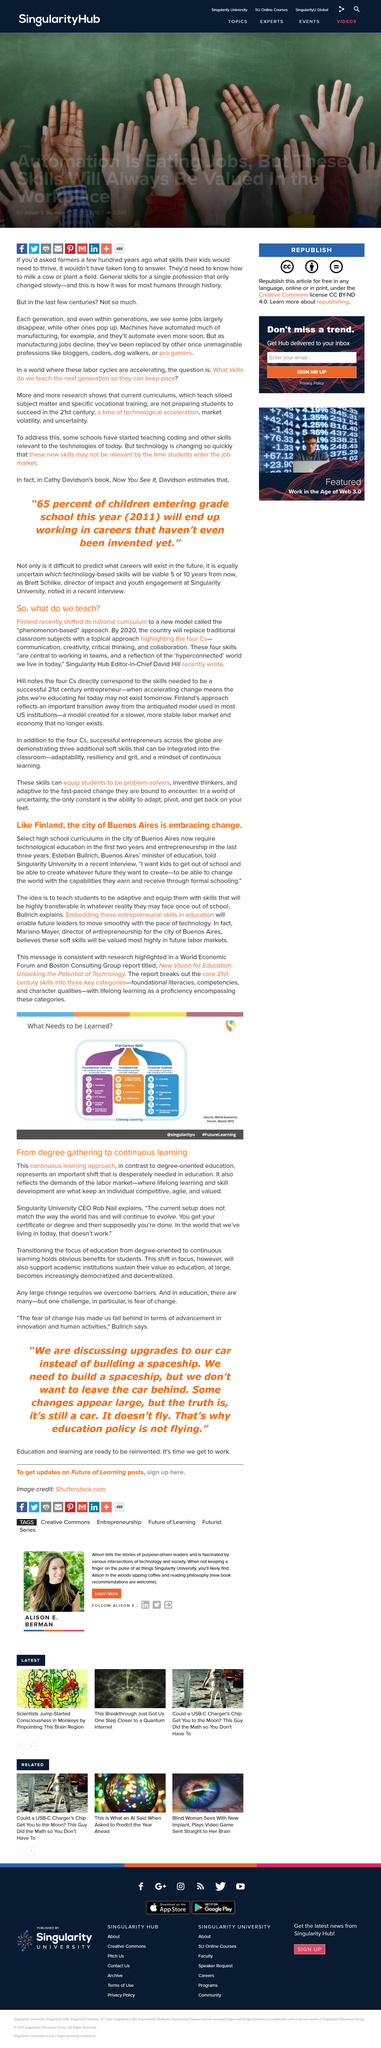Identify some key points in this picture. The core 21st-century skills consist of three key categories. Competency is a crucial category, as is the case with, "Yes, it is. Finland is currently implementing a phenomenon-based approach in its national curriculum model. Singularity University prioritizes the continuous learning approach to education over the traditional "degree gathering" approach. By embedding entrepreneurial skills in education, future leaders will be equipped to keep pace with the rapid advancements in technology, thereby allowing them to effectively lead and succeed in an ever-changing world. 